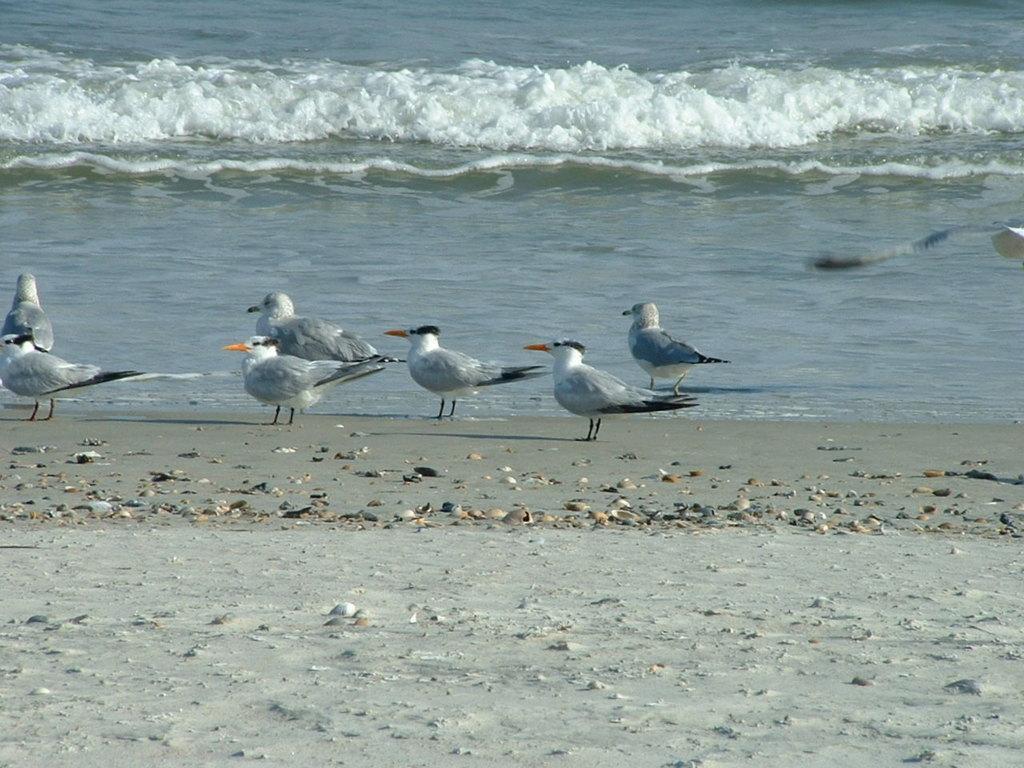How would you summarize this image in a sentence or two? In this picture i can see group of birds on the ground. In the background i can see water. 